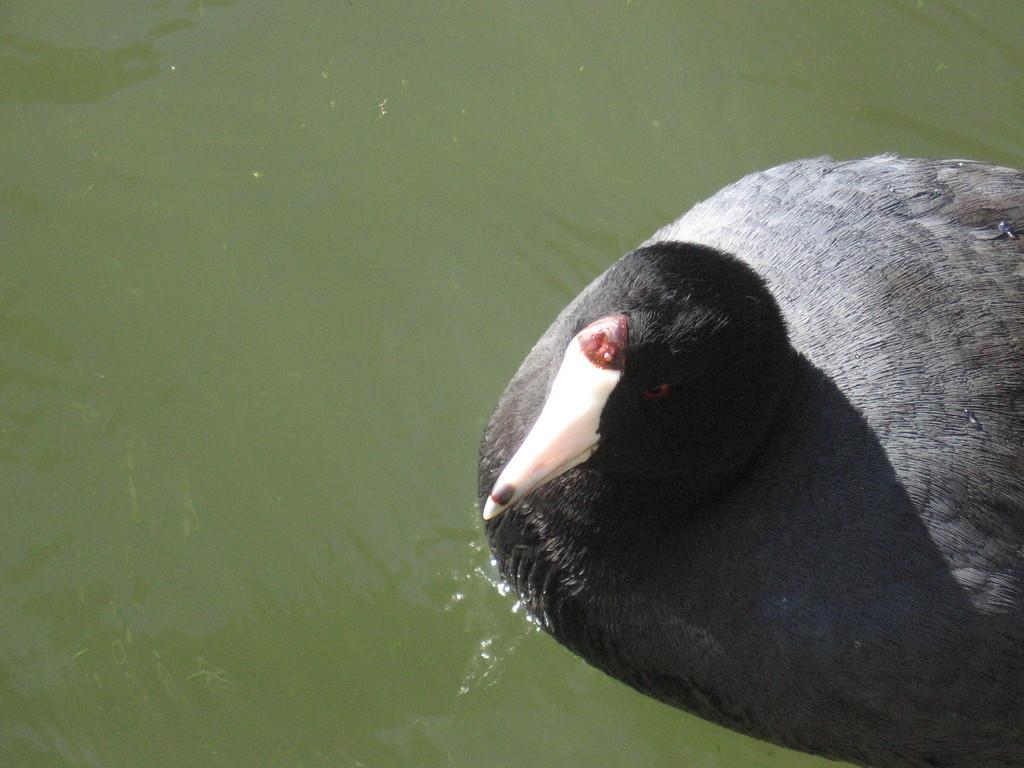What type of animal can be seen in the image? There is a bird in the image. Where is the bird located? The bird is on the water. What colors can be observed on the bird? The bird has black, grey, and white colors. What type of toys can be seen in the bird's pocket in the image? There are no toys or pockets present on the bird in the image. 